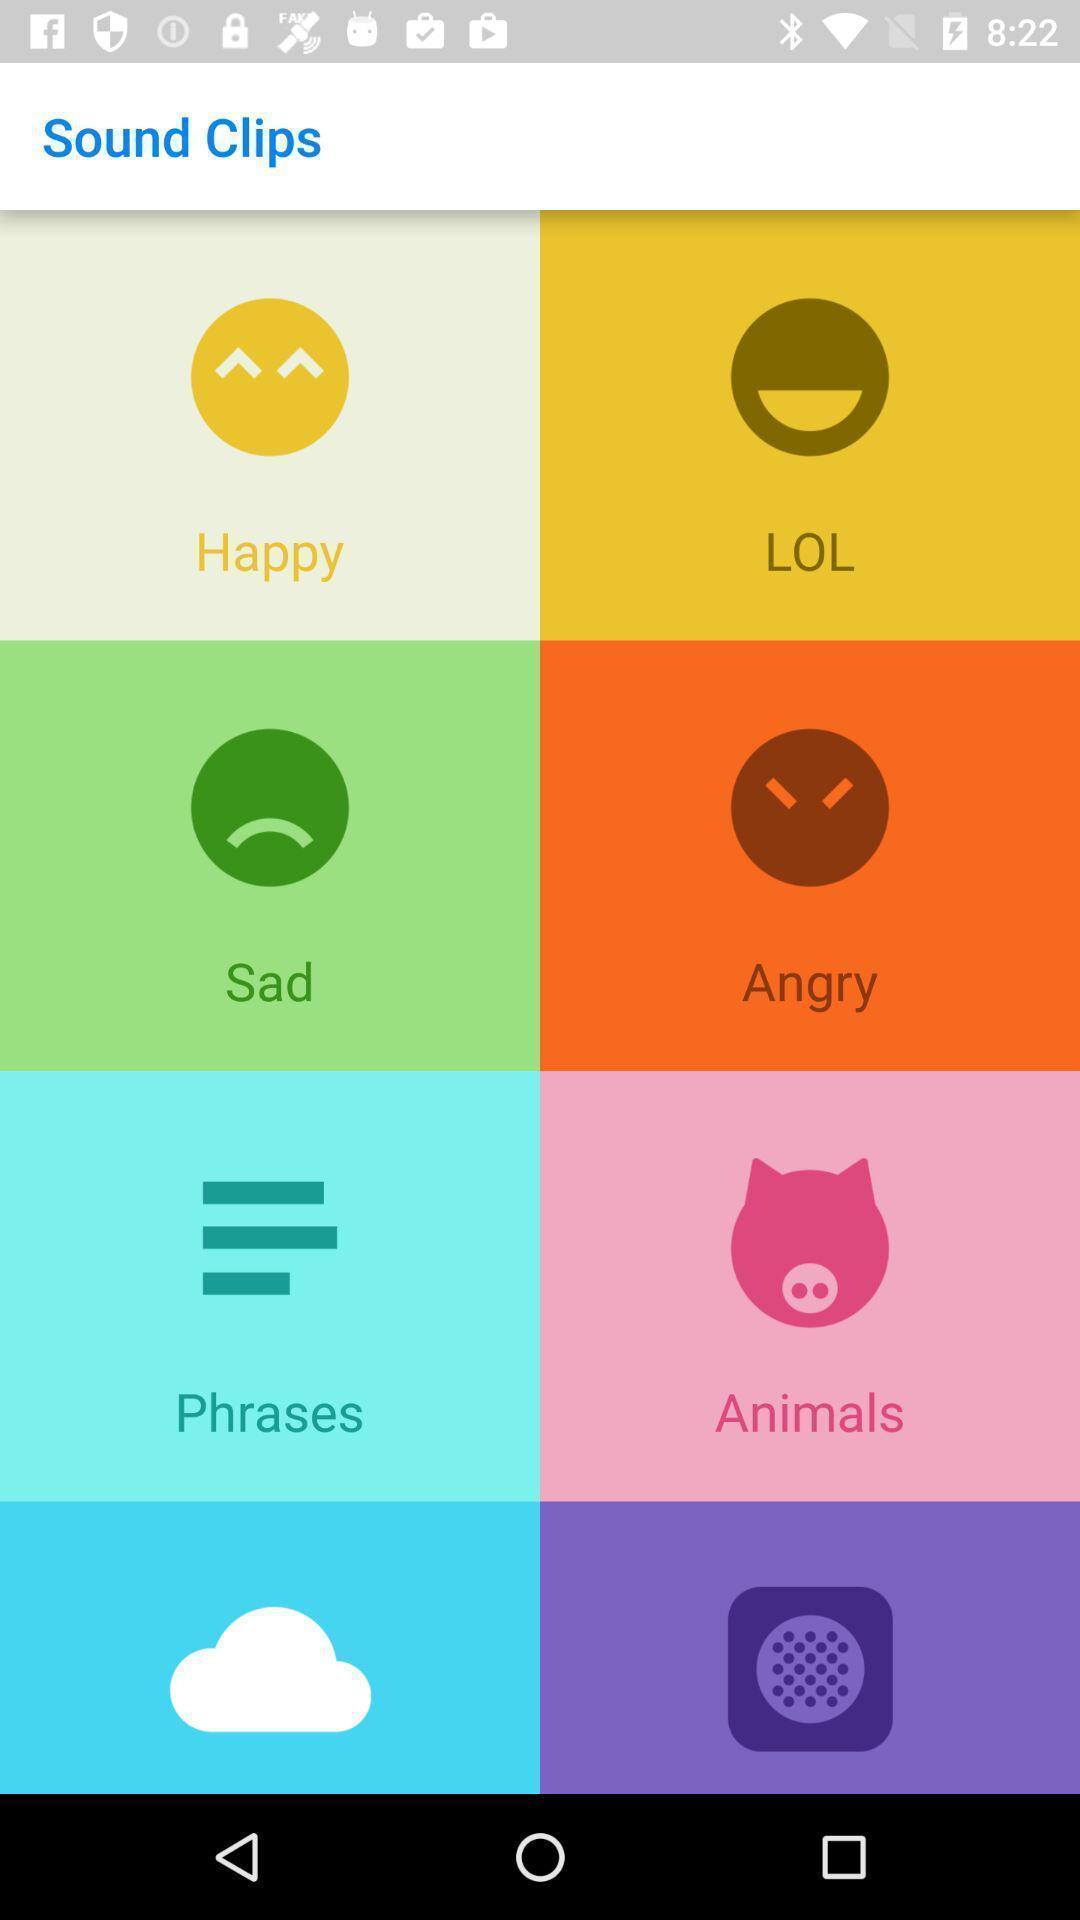Provide a description of this screenshot. Page shows results for sound clips with few emojis. 